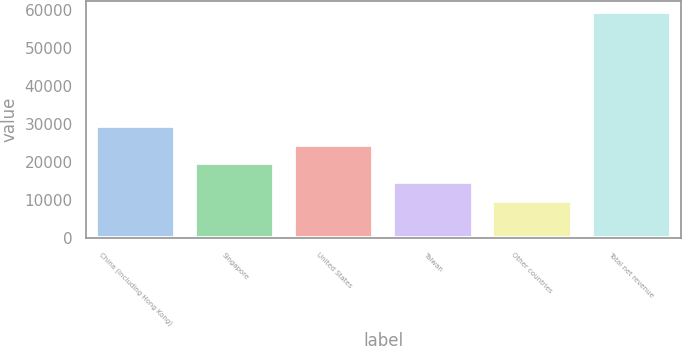Convert chart to OTSL. <chart><loc_0><loc_0><loc_500><loc_500><bar_chart><fcel>China (including Hong Kong)<fcel>Singapore<fcel>United States<fcel>Taiwan<fcel>Other countries<fcel>Total net revenue<nl><fcel>29586.8<fcel>19653.4<fcel>24620.1<fcel>14686.7<fcel>9720<fcel>59387<nl></chart> 